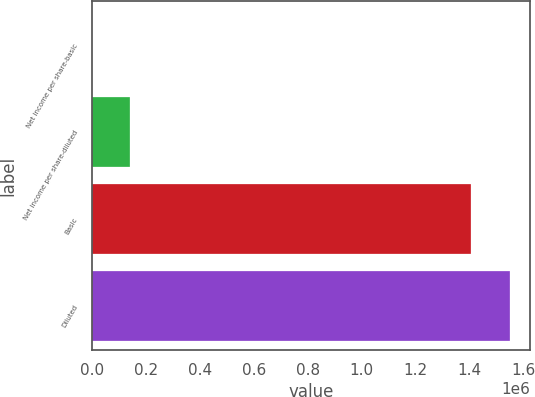Convert chart. <chart><loc_0><loc_0><loc_500><loc_500><bar_chart><fcel>Net income per share-basic<fcel>Net income per share-diluted<fcel>Basic<fcel>Diluted<nl><fcel>0.2<fcel>142611<fcel>1.40638e+06<fcel>1.54899e+06<nl></chart> 